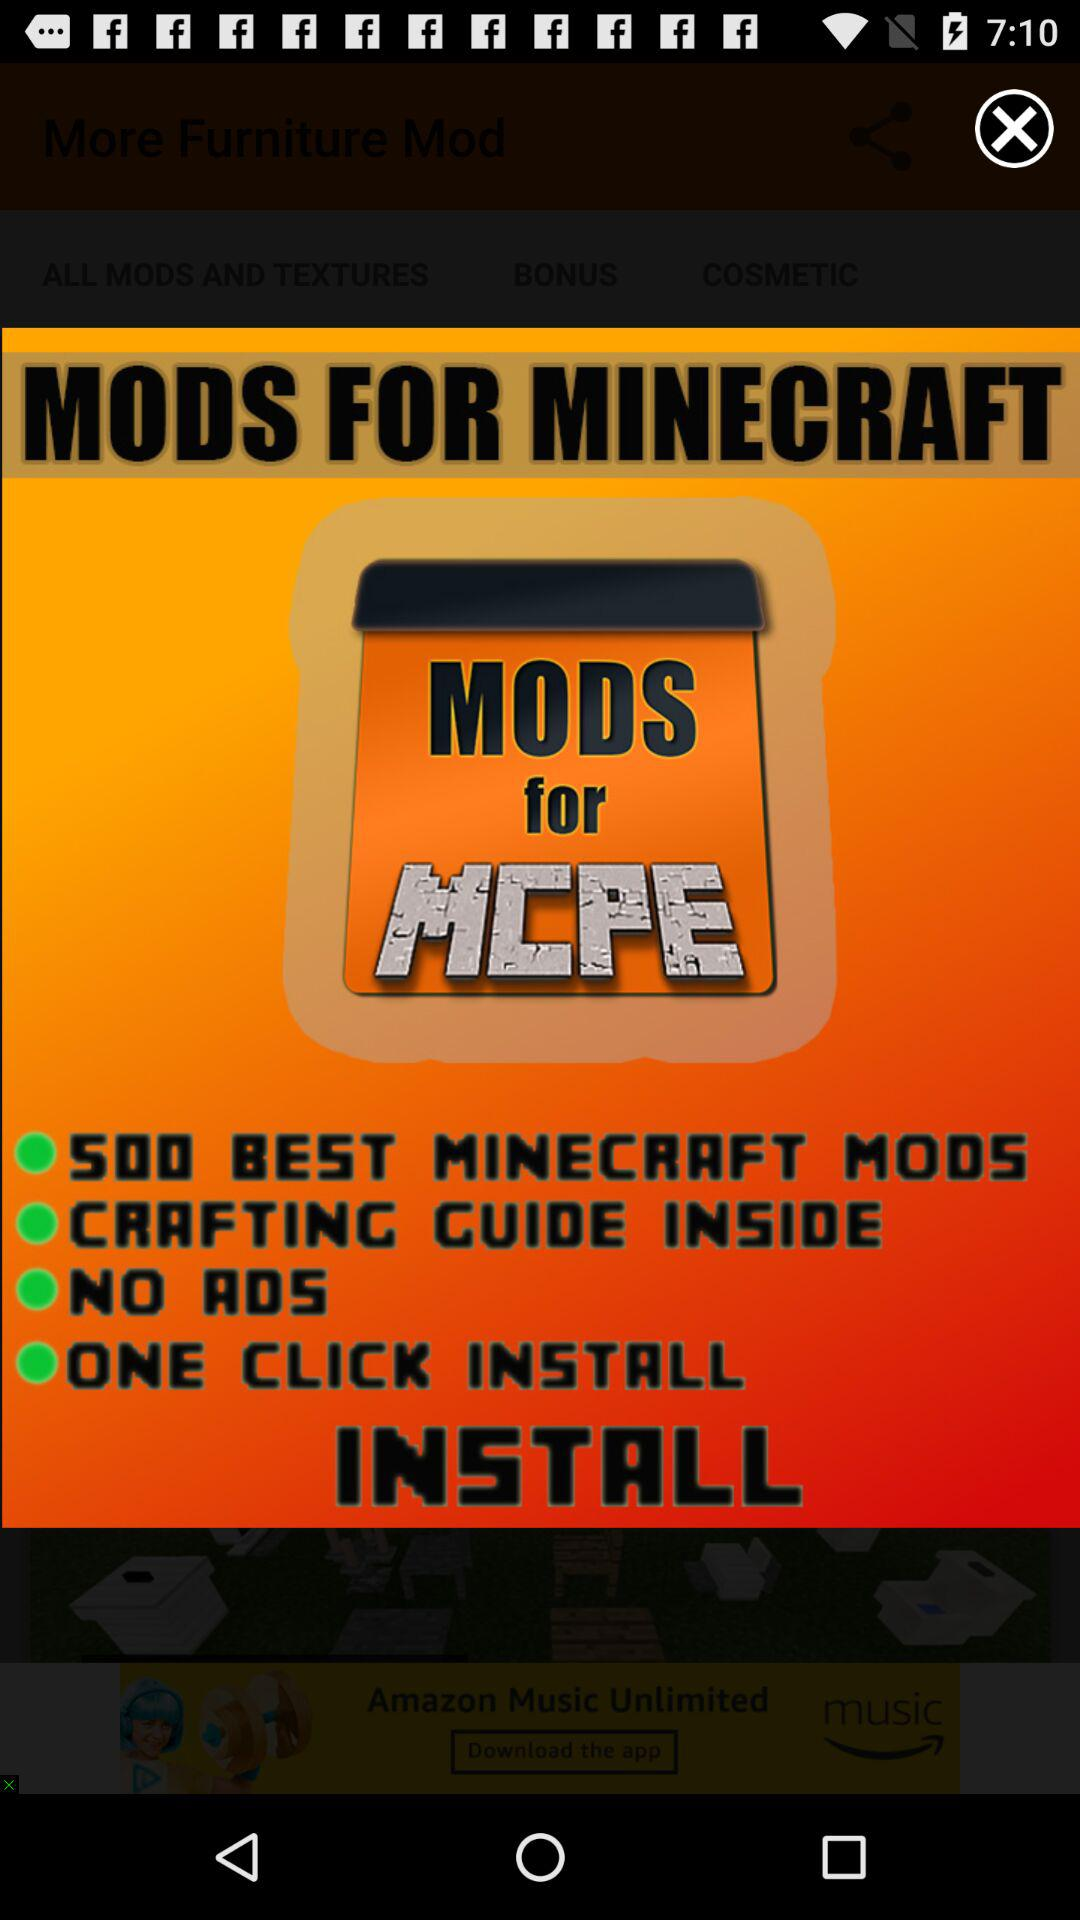What is the application name? The application name is "MODS FOR MINECRAFT". 